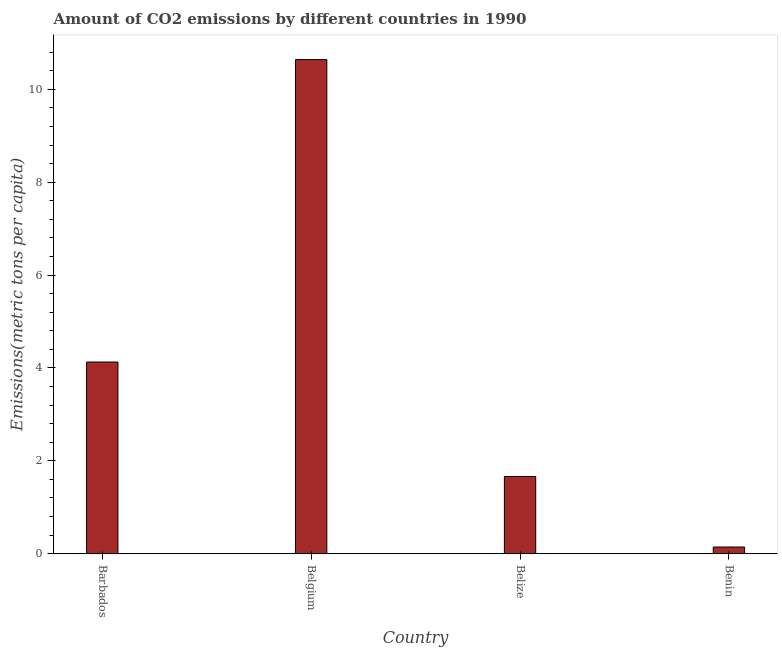Does the graph contain grids?
Give a very brief answer. No. What is the title of the graph?
Give a very brief answer. Amount of CO2 emissions by different countries in 1990. What is the label or title of the X-axis?
Your answer should be very brief. Country. What is the label or title of the Y-axis?
Your answer should be very brief. Emissions(metric tons per capita). What is the amount of co2 emissions in Belgium?
Make the answer very short. 10.64. Across all countries, what is the maximum amount of co2 emissions?
Your response must be concise. 10.64. Across all countries, what is the minimum amount of co2 emissions?
Provide a short and direct response. 0.14. In which country was the amount of co2 emissions maximum?
Offer a terse response. Belgium. In which country was the amount of co2 emissions minimum?
Your answer should be very brief. Benin. What is the sum of the amount of co2 emissions?
Provide a succinct answer. 16.57. What is the difference between the amount of co2 emissions in Belgium and Belize?
Your answer should be compact. 8.98. What is the average amount of co2 emissions per country?
Give a very brief answer. 4.14. What is the median amount of co2 emissions?
Your answer should be very brief. 2.89. What is the ratio of the amount of co2 emissions in Barbados to that in Benin?
Provide a succinct answer. 28.86. Is the difference between the amount of co2 emissions in Belgium and Benin greater than the difference between any two countries?
Offer a very short reply. Yes. What is the difference between the highest and the second highest amount of co2 emissions?
Ensure brevity in your answer.  6.51. Are all the bars in the graph horizontal?
Your answer should be very brief. No. What is the Emissions(metric tons per capita) in Barbados?
Your answer should be very brief. 4.13. What is the Emissions(metric tons per capita) of Belgium?
Your response must be concise. 10.64. What is the Emissions(metric tons per capita) of Belize?
Keep it short and to the point. 1.66. What is the Emissions(metric tons per capita) of Benin?
Offer a terse response. 0.14. What is the difference between the Emissions(metric tons per capita) in Barbados and Belgium?
Keep it short and to the point. -6.51. What is the difference between the Emissions(metric tons per capita) in Barbados and Belize?
Provide a short and direct response. 2.46. What is the difference between the Emissions(metric tons per capita) in Barbados and Benin?
Your answer should be compact. 3.98. What is the difference between the Emissions(metric tons per capita) in Belgium and Belize?
Offer a very short reply. 8.98. What is the difference between the Emissions(metric tons per capita) in Belgium and Benin?
Your answer should be compact. 10.5. What is the difference between the Emissions(metric tons per capita) in Belize and Benin?
Make the answer very short. 1.52. What is the ratio of the Emissions(metric tons per capita) in Barbados to that in Belgium?
Ensure brevity in your answer.  0.39. What is the ratio of the Emissions(metric tons per capita) in Barbados to that in Belize?
Provide a short and direct response. 2.48. What is the ratio of the Emissions(metric tons per capita) in Barbados to that in Benin?
Your answer should be very brief. 28.86. What is the ratio of the Emissions(metric tons per capita) in Belgium to that in Belize?
Your answer should be compact. 6.4. What is the ratio of the Emissions(metric tons per capita) in Belgium to that in Benin?
Provide a succinct answer. 74.42. What is the ratio of the Emissions(metric tons per capita) in Belize to that in Benin?
Your answer should be very brief. 11.62. 